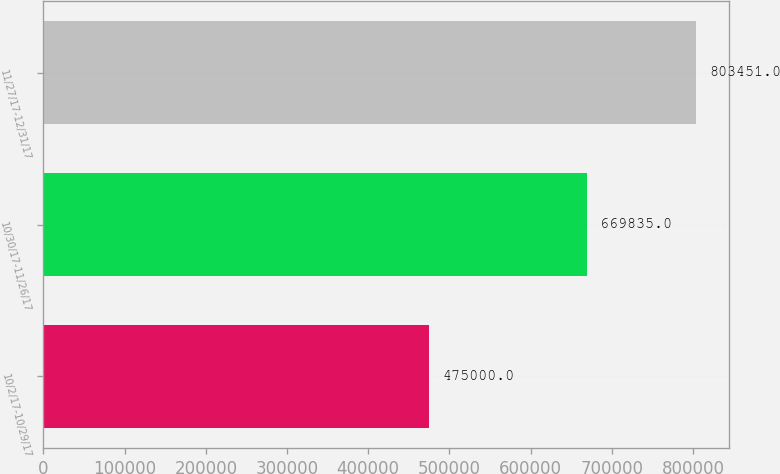Convert chart. <chart><loc_0><loc_0><loc_500><loc_500><bar_chart><fcel>10/2/17-10/29/17<fcel>10/30/17-11/26/17<fcel>11/27/17-12/31/17<nl><fcel>475000<fcel>669835<fcel>803451<nl></chart> 